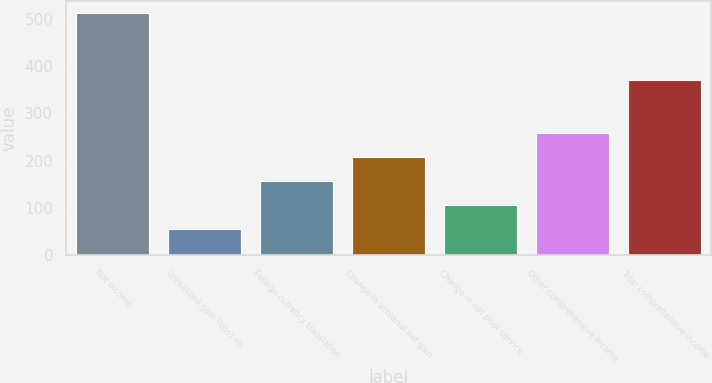Convert chart. <chart><loc_0><loc_0><loc_500><loc_500><bar_chart><fcel>Net income<fcel>Unrealized gain (loss) on<fcel>Foreign currency translation<fcel>Change in actuarial net gain<fcel>Change in net prior service<fcel>Other comprehensive income<fcel>Total comprehensive income<nl><fcel>513<fcel>55.8<fcel>157.4<fcel>208.2<fcel>106.6<fcel>259<fcel>370<nl></chart> 